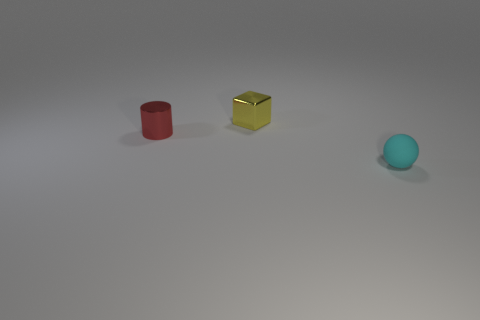Add 2 green cubes. How many objects exist? 5 Subtract all blocks. How many objects are left? 2 Subtract 0 green cylinders. How many objects are left? 3 Subtract all red things. Subtract all small yellow metallic things. How many objects are left? 1 Add 1 small yellow objects. How many small yellow objects are left? 2 Add 3 metal things. How many metal things exist? 5 